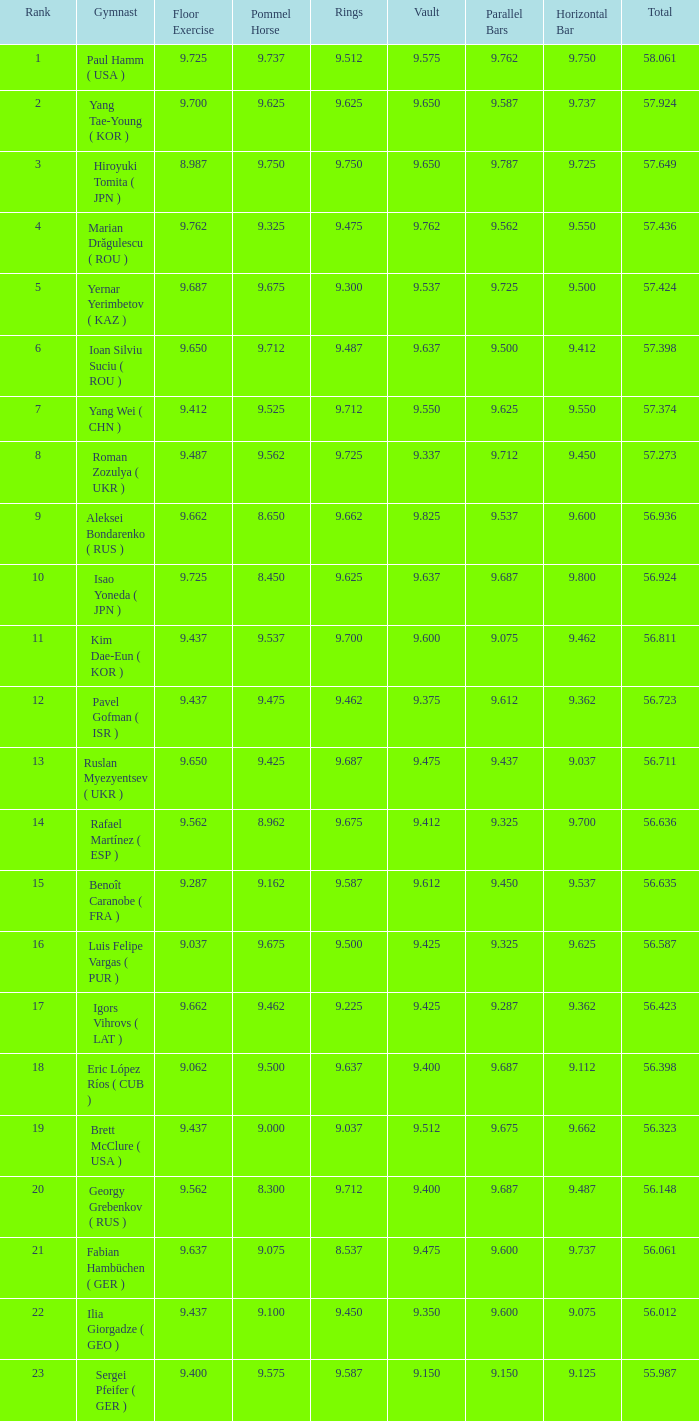What is the vault score for the combined total of 5 9.612. 